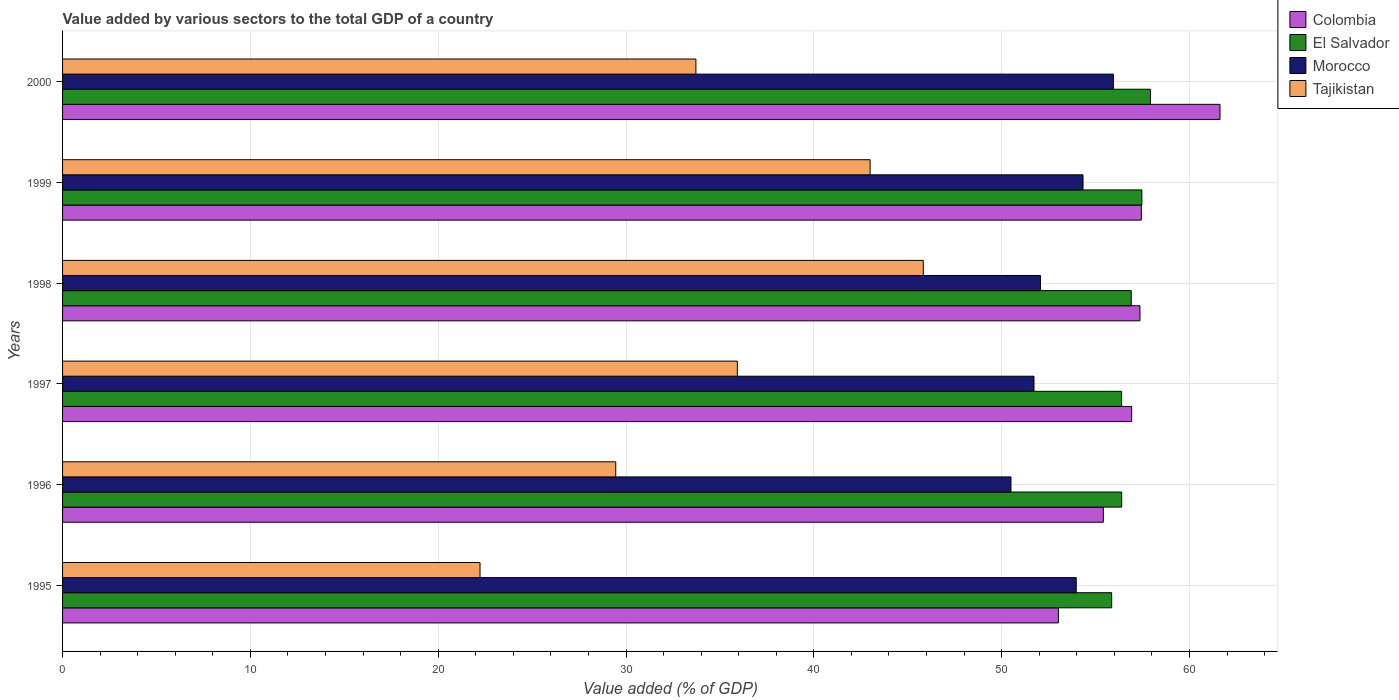How many different coloured bars are there?
Provide a short and direct response. 4. How many groups of bars are there?
Your answer should be compact. 6. How many bars are there on the 2nd tick from the bottom?
Your answer should be compact. 4. In how many cases, is the number of bars for a given year not equal to the number of legend labels?
Offer a terse response. 0. What is the value added by various sectors to the total GDP in Morocco in 1995?
Provide a succinct answer. 53.97. Across all years, what is the maximum value added by various sectors to the total GDP in Morocco?
Your answer should be very brief. 55.95. Across all years, what is the minimum value added by various sectors to the total GDP in Morocco?
Make the answer very short. 50.5. In which year was the value added by various sectors to the total GDP in Colombia maximum?
Your answer should be compact. 2000. What is the total value added by various sectors to the total GDP in Tajikistan in the graph?
Provide a short and direct response. 210.16. What is the difference between the value added by various sectors to the total GDP in Morocco in 1997 and that in 1999?
Your answer should be very brief. -2.61. What is the difference between the value added by various sectors to the total GDP in Colombia in 1998 and the value added by various sectors to the total GDP in Morocco in 1997?
Your answer should be compact. 5.64. What is the average value added by various sectors to the total GDP in El Salvador per year?
Offer a terse response. 56.82. In the year 2000, what is the difference between the value added by various sectors to the total GDP in Colombia and value added by various sectors to the total GDP in Tajikistan?
Make the answer very short. 27.91. What is the ratio of the value added by various sectors to the total GDP in Tajikistan in 1995 to that in 1997?
Make the answer very short. 0.62. Is the difference between the value added by various sectors to the total GDP in Colombia in 1997 and 2000 greater than the difference between the value added by various sectors to the total GDP in Tajikistan in 1997 and 2000?
Your answer should be compact. No. What is the difference between the highest and the second highest value added by various sectors to the total GDP in Tajikistan?
Give a very brief answer. 2.83. What is the difference between the highest and the lowest value added by various sectors to the total GDP in Morocco?
Provide a succinct answer. 5.45. What does the 4th bar from the top in 1999 represents?
Ensure brevity in your answer.  Colombia. How many bars are there?
Provide a short and direct response. 24. Does the graph contain any zero values?
Provide a short and direct response. No. Does the graph contain grids?
Your response must be concise. Yes. What is the title of the graph?
Provide a succinct answer. Value added by various sectors to the total GDP of a country. Does "Central Europe" appear as one of the legend labels in the graph?
Your answer should be very brief. No. What is the label or title of the X-axis?
Provide a succinct answer. Value added (% of GDP). What is the label or title of the Y-axis?
Give a very brief answer. Years. What is the Value added (% of GDP) of Colombia in 1995?
Offer a terse response. 53.02. What is the Value added (% of GDP) of El Salvador in 1995?
Your response must be concise. 55.86. What is the Value added (% of GDP) in Morocco in 1995?
Provide a succinct answer. 53.97. What is the Value added (% of GDP) in Tajikistan in 1995?
Your answer should be very brief. 22.23. What is the Value added (% of GDP) in Colombia in 1996?
Offer a terse response. 55.42. What is the Value added (% of GDP) in El Salvador in 1996?
Provide a short and direct response. 56.39. What is the Value added (% of GDP) in Morocco in 1996?
Make the answer very short. 50.5. What is the Value added (% of GDP) of Tajikistan in 1996?
Provide a short and direct response. 29.45. What is the Value added (% of GDP) of Colombia in 1997?
Provide a short and direct response. 56.92. What is the Value added (% of GDP) of El Salvador in 1997?
Give a very brief answer. 56.39. What is the Value added (% of GDP) in Morocco in 1997?
Make the answer very short. 51.72. What is the Value added (% of GDP) in Tajikistan in 1997?
Offer a very short reply. 35.93. What is the Value added (% of GDP) of Colombia in 1998?
Your answer should be compact. 57.37. What is the Value added (% of GDP) of El Salvador in 1998?
Ensure brevity in your answer.  56.9. What is the Value added (% of GDP) in Morocco in 1998?
Offer a terse response. 52.07. What is the Value added (% of GDP) of Tajikistan in 1998?
Your response must be concise. 45.83. What is the Value added (% of GDP) of Colombia in 1999?
Offer a terse response. 57.44. What is the Value added (% of GDP) of El Salvador in 1999?
Offer a very short reply. 57.47. What is the Value added (% of GDP) in Morocco in 1999?
Ensure brevity in your answer.  54.33. What is the Value added (% of GDP) in Tajikistan in 1999?
Your response must be concise. 43. What is the Value added (% of GDP) in Colombia in 2000?
Your response must be concise. 61.63. What is the Value added (% of GDP) of El Salvador in 2000?
Ensure brevity in your answer.  57.92. What is the Value added (% of GDP) of Morocco in 2000?
Your response must be concise. 55.95. What is the Value added (% of GDP) of Tajikistan in 2000?
Provide a succinct answer. 33.72. Across all years, what is the maximum Value added (% of GDP) in Colombia?
Provide a succinct answer. 61.63. Across all years, what is the maximum Value added (% of GDP) of El Salvador?
Keep it short and to the point. 57.92. Across all years, what is the maximum Value added (% of GDP) of Morocco?
Ensure brevity in your answer.  55.95. Across all years, what is the maximum Value added (% of GDP) of Tajikistan?
Offer a terse response. 45.83. Across all years, what is the minimum Value added (% of GDP) of Colombia?
Your answer should be very brief. 53.02. Across all years, what is the minimum Value added (% of GDP) of El Salvador?
Your answer should be compact. 55.86. Across all years, what is the minimum Value added (% of GDP) of Morocco?
Give a very brief answer. 50.5. Across all years, what is the minimum Value added (% of GDP) of Tajikistan?
Your response must be concise. 22.23. What is the total Value added (% of GDP) in Colombia in the graph?
Offer a terse response. 341.8. What is the total Value added (% of GDP) of El Salvador in the graph?
Make the answer very short. 340.93. What is the total Value added (% of GDP) in Morocco in the graph?
Provide a short and direct response. 318.55. What is the total Value added (% of GDP) in Tajikistan in the graph?
Your answer should be compact. 210.16. What is the difference between the Value added (% of GDP) in Colombia in 1995 and that in 1996?
Give a very brief answer. -2.39. What is the difference between the Value added (% of GDP) in El Salvador in 1995 and that in 1996?
Provide a short and direct response. -0.53. What is the difference between the Value added (% of GDP) of Morocco in 1995 and that in 1996?
Ensure brevity in your answer.  3.48. What is the difference between the Value added (% of GDP) in Tajikistan in 1995 and that in 1996?
Your answer should be compact. -7.23. What is the difference between the Value added (% of GDP) of Colombia in 1995 and that in 1997?
Your answer should be compact. -3.9. What is the difference between the Value added (% of GDP) in El Salvador in 1995 and that in 1997?
Your answer should be very brief. -0.53. What is the difference between the Value added (% of GDP) in Morocco in 1995 and that in 1997?
Your answer should be very brief. 2.25. What is the difference between the Value added (% of GDP) in Tajikistan in 1995 and that in 1997?
Keep it short and to the point. -13.7. What is the difference between the Value added (% of GDP) of Colombia in 1995 and that in 1998?
Offer a terse response. -4.34. What is the difference between the Value added (% of GDP) of El Salvador in 1995 and that in 1998?
Your answer should be very brief. -1.04. What is the difference between the Value added (% of GDP) of Morocco in 1995 and that in 1998?
Your response must be concise. 1.91. What is the difference between the Value added (% of GDP) in Tajikistan in 1995 and that in 1998?
Provide a succinct answer. -23.6. What is the difference between the Value added (% of GDP) in Colombia in 1995 and that in 1999?
Your answer should be very brief. -4.42. What is the difference between the Value added (% of GDP) of El Salvador in 1995 and that in 1999?
Provide a short and direct response. -1.61. What is the difference between the Value added (% of GDP) of Morocco in 1995 and that in 1999?
Make the answer very short. -0.36. What is the difference between the Value added (% of GDP) in Tajikistan in 1995 and that in 1999?
Offer a terse response. -20.77. What is the difference between the Value added (% of GDP) of Colombia in 1995 and that in 2000?
Your response must be concise. -8.6. What is the difference between the Value added (% of GDP) in El Salvador in 1995 and that in 2000?
Offer a terse response. -2.06. What is the difference between the Value added (% of GDP) of Morocco in 1995 and that in 2000?
Ensure brevity in your answer.  -1.98. What is the difference between the Value added (% of GDP) in Tajikistan in 1995 and that in 2000?
Provide a succinct answer. -11.5. What is the difference between the Value added (% of GDP) of Colombia in 1996 and that in 1997?
Ensure brevity in your answer.  -1.51. What is the difference between the Value added (% of GDP) in El Salvador in 1996 and that in 1997?
Provide a succinct answer. 0. What is the difference between the Value added (% of GDP) of Morocco in 1996 and that in 1997?
Provide a short and direct response. -1.23. What is the difference between the Value added (% of GDP) of Tajikistan in 1996 and that in 1997?
Provide a succinct answer. -6.48. What is the difference between the Value added (% of GDP) of Colombia in 1996 and that in 1998?
Provide a short and direct response. -1.95. What is the difference between the Value added (% of GDP) of El Salvador in 1996 and that in 1998?
Keep it short and to the point. -0.51. What is the difference between the Value added (% of GDP) of Morocco in 1996 and that in 1998?
Make the answer very short. -1.57. What is the difference between the Value added (% of GDP) of Tajikistan in 1996 and that in 1998?
Your response must be concise. -16.37. What is the difference between the Value added (% of GDP) of Colombia in 1996 and that in 1999?
Make the answer very short. -2.02. What is the difference between the Value added (% of GDP) of El Salvador in 1996 and that in 1999?
Ensure brevity in your answer.  -1.07. What is the difference between the Value added (% of GDP) in Morocco in 1996 and that in 1999?
Provide a succinct answer. -3.84. What is the difference between the Value added (% of GDP) of Tajikistan in 1996 and that in 1999?
Make the answer very short. -13.54. What is the difference between the Value added (% of GDP) in Colombia in 1996 and that in 2000?
Your response must be concise. -6.21. What is the difference between the Value added (% of GDP) in El Salvador in 1996 and that in 2000?
Offer a terse response. -1.53. What is the difference between the Value added (% of GDP) in Morocco in 1996 and that in 2000?
Your answer should be very brief. -5.45. What is the difference between the Value added (% of GDP) of Tajikistan in 1996 and that in 2000?
Offer a terse response. -4.27. What is the difference between the Value added (% of GDP) of Colombia in 1997 and that in 1998?
Your response must be concise. -0.44. What is the difference between the Value added (% of GDP) of El Salvador in 1997 and that in 1998?
Offer a very short reply. -0.51. What is the difference between the Value added (% of GDP) of Morocco in 1997 and that in 1998?
Your response must be concise. -0.34. What is the difference between the Value added (% of GDP) in Tajikistan in 1997 and that in 1998?
Provide a succinct answer. -9.9. What is the difference between the Value added (% of GDP) of Colombia in 1997 and that in 1999?
Give a very brief answer. -0.52. What is the difference between the Value added (% of GDP) of El Salvador in 1997 and that in 1999?
Provide a short and direct response. -1.08. What is the difference between the Value added (% of GDP) in Morocco in 1997 and that in 1999?
Provide a succinct answer. -2.61. What is the difference between the Value added (% of GDP) of Tajikistan in 1997 and that in 1999?
Ensure brevity in your answer.  -7.07. What is the difference between the Value added (% of GDP) of Colombia in 1997 and that in 2000?
Offer a very short reply. -4.7. What is the difference between the Value added (% of GDP) of El Salvador in 1997 and that in 2000?
Offer a terse response. -1.53. What is the difference between the Value added (% of GDP) in Morocco in 1997 and that in 2000?
Give a very brief answer. -4.23. What is the difference between the Value added (% of GDP) in Tajikistan in 1997 and that in 2000?
Your answer should be very brief. 2.21. What is the difference between the Value added (% of GDP) of Colombia in 1998 and that in 1999?
Make the answer very short. -0.07. What is the difference between the Value added (% of GDP) in El Salvador in 1998 and that in 1999?
Make the answer very short. -0.57. What is the difference between the Value added (% of GDP) in Morocco in 1998 and that in 1999?
Your answer should be compact. -2.27. What is the difference between the Value added (% of GDP) of Tajikistan in 1998 and that in 1999?
Make the answer very short. 2.83. What is the difference between the Value added (% of GDP) in Colombia in 1998 and that in 2000?
Offer a terse response. -4.26. What is the difference between the Value added (% of GDP) of El Salvador in 1998 and that in 2000?
Offer a terse response. -1.02. What is the difference between the Value added (% of GDP) in Morocco in 1998 and that in 2000?
Your answer should be very brief. -3.88. What is the difference between the Value added (% of GDP) in Tajikistan in 1998 and that in 2000?
Your answer should be very brief. 12.11. What is the difference between the Value added (% of GDP) in Colombia in 1999 and that in 2000?
Your response must be concise. -4.19. What is the difference between the Value added (% of GDP) in El Salvador in 1999 and that in 2000?
Provide a short and direct response. -0.46. What is the difference between the Value added (% of GDP) of Morocco in 1999 and that in 2000?
Make the answer very short. -1.62. What is the difference between the Value added (% of GDP) of Tajikistan in 1999 and that in 2000?
Give a very brief answer. 9.27. What is the difference between the Value added (% of GDP) in Colombia in 1995 and the Value added (% of GDP) in El Salvador in 1996?
Offer a very short reply. -3.37. What is the difference between the Value added (% of GDP) of Colombia in 1995 and the Value added (% of GDP) of Morocco in 1996?
Give a very brief answer. 2.53. What is the difference between the Value added (% of GDP) of Colombia in 1995 and the Value added (% of GDP) of Tajikistan in 1996?
Provide a succinct answer. 23.57. What is the difference between the Value added (% of GDP) in El Salvador in 1995 and the Value added (% of GDP) in Morocco in 1996?
Your answer should be compact. 5.36. What is the difference between the Value added (% of GDP) in El Salvador in 1995 and the Value added (% of GDP) in Tajikistan in 1996?
Offer a terse response. 26.41. What is the difference between the Value added (% of GDP) in Morocco in 1995 and the Value added (% of GDP) in Tajikistan in 1996?
Keep it short and to the point. 24.52. What is the difference between the Value added (% of GDP) in Colombia in 1995 and the Value added (% of GDP) in El Salvador in 1997?
Give a very brief answer. -3.36. What is the difference between the Value added (% of GDP) of Colombia in 1995 and the Value added (% of GDP) of Morocco in 1997?
Make the answer very short. 1.3. What is the difference between the Value added (% of GDP) in Colombia in 1995 and the Value added (% of GDP) in Tajikistan in 1997?
Make the answer very short. 17.09. What is the difference between the Value added (% of GDP) of El Salvador in 1995 and the Value added (% of GDP) of Morocco in 1997?
Ensure brevity in your answer.  4.14. What is the difference between the Value added (% of GDP) of El Salvador in 1995 and the Value added (% of GDP) of Tajikistan in 1997?
Your answer should be compact. 19.93. What is the difference between the Value added (% of GDP) in Morocco in 1995 and the Value added (% of GDP) in Tajikistan in 1997?
Provide a short and direct response. 18.04. What is the difference between the Value added (% of GDP) of Colombia in 1995 and the Value added (% of GDP) of El Salvador in 1998?
Your response must be concise. -3.88. What is the difference between the Value added (% of GDP) in Colombia in 1995 and the Value added (% of GDP) in Morocco in 1998?
Make the answer very short. 0.96. What is the difference between the Value added (% of GDP) of Colombia in 1995 and the Value added (% of GDP) of Tajikistan in 1998?
Your answer should be compact. 7.19. What is the difference between the Value added (% of GDP) in El Salvador in 1995 and the Value added (% of GDP) in Morocco in 1998?
Provide a succinct answer. 3.79. What is the difference between the Value added (% of GDP) of El Salvador in 1995 and the Value added (% of GDP) of Tajikistan in 1998?
Give a very brief answer. 10.03. What is the difference between the Value added (% of GDP) of Morocco in 1995 and the Value added (% of GDP) of Tajikistan in 1998?
Keep it short and to the point. 8.14. What is the difference between the Value added (% of GDP) of Colombia in 1995 and the Value added (% of GDP) of El Salvador in 1999?
Your response must be concise. -4.44. What is the difference between the Value added (% of GDP) in Colombia in 1995 and the Value added (% of GDP) in Morocco in 1999?
Provide a succinct answer. -1.31. What is the difference between the Value added (% of GDP) of Colombia in 1995 and the Value added (% of GDP) of Tajikistan in 1999?
Give a very brief answer. 10.03. What is the difference between the Value added (% of GDP) in El Salvador in 1995 and the Value added (% of GDP) in Morocco in 1999?
Offer a terse response. 1.53. What is the difference between the Value added (% of GDP) in El Salvador in 1995 and the Value added (% of GDP) in Tajikistan in 1999?
Offer a terse response. 12.86. What is the difference between the Value added (% of GDP) of Morocco in 1995 and the Value added (% of GDP) of Tajikistan in 1999?
Ensure brevity in your answer.  10.98. What is the difference between the Value added (% of GDP) of Colombia in 1995 and the Value added (% of GDP) of El Salvador in 2000?
Your answer should be compact. -4.9. What is the difference between the Value added (% of GDP) of Colombia in 1995 and the Value added (% of GDP) of Morocco in 2000?
Make the answer very short. -2.93. What is the difference between the Value added (% of GDP) of Colombia in 1995 and the Value added (% of GDP) of Tajikistan in 2000?
Make the answer very short. 19.3. What is the difference between the Value added (% of GDP) in El Salvador in 1995 and the Value added (% of GDP) in Morocco in 2000?
Keep it short and to the point. -0.09. What is the difference between the Value added (% of GDP) in El Salvador in 1995 and the Value added (% of GDP) in Tajikistan in 2000?
Your answer should be compact. 22.14. What is the difference between the Value added (% of GDP) in Morocco in 1995 and the Value added (% of GDP) in Tajikistan in 2000?
Provide a short and direct response. 20.25. What is the difference between the Value added (% of GDP) of Colombia in 1996 and the Value added (% of GDP) of El Salvador in 1997?
Your response must be concise. -0.97. What is the difference between the Value added (% of GDP) in Colombia in 1996 and the Value added (% of GDP) in Morocco in 1997?
Your response must be concise. 3.69. What is the difference between the Value added (% of GDP) of Colombia in 1996 and the Value added (% of GDP) of Tajikistan in 1997?
Offer a terse response. 19.49. What is the difference between the Value added (% of GDP) in El Salvador in 1996 and the Value added (% of GDP) in Morocco in 1997?
Give a very brief answer. 4.67. What is the difference between the Value added (% of GDP) of El Salvador in 1996 and the Value added (% of GDP) of Tajikistan in 1997?
Your answer should be compact. 20.46. What is the difference between the Value added (% of GDP) in Morocco in 1996 and the Value added (% of GDP) in Tajikistan in 1997?
Ensure brevity in your answer.  14.57. What is the difference between the Value added (% of GDP) in Colombia in 1996 and the Value added (% of GDP) in El Salvador in 1998?
Your answer should be very brief. -1.49. What is the difference between the Value added (% of GDP) of Colombia in 1996 and the Value added (% of GDP) of Morocco in 1998?
Your answer should be compact. 3.35. What is the difference between the Value added (% of GDP) of Colombia in 1996 and the Value added (% of GDP) of Tajikistan in 1998?
Provide a succinct answer. 9.59. What is the difference between the Value added (% of GDP) of El Salvador in 1996 and the Value added (% of GDP) of Morocco in 1998?
Your answer should be very brief. 4.32. What is the difference between the Value added (% of GDP) of El Salvador in 1996 and the Value added (% of GDP) of Tajikistan in 1998?
Your response must be concise. 10.56. What is the difference between the Value added (% of GDP) in Morocco in 1996 and the Value added (% of GDP) in Tajikistan in 1998?
Your answer should be compact. 4.67. What is the difference between the Value added (% of GDP) in Colombia in 1996 and the Value added (% of GDP) in El Salvador in 1999?
Provide a short and direct response. -2.05. What is the difference between the Value added (% of GDP) in Colombia in 1996 and the Value added (% of GDP) in Morocco in 1999?
Keep it short and to the point. 1.08. What is the difference between the Value added (% of GDP) in Colombia in 1996 and the Value added (% of GDP) in Tajikistan in 1999?
Your answer should be compact. 12.42. What is the difference between the Value added (% of GDP) in El Salvador in 1996 and the Value added (% of GDP) in Morocco in 1999?
Your answer should be compact. 2.06. What is the difference between the Value added (% of GDP) of El Salvador in 1996 and the Value added (% of GDP) of Tajikistan in 1999?
Offer a very short reply. 13.39. What is the difference between the Value added (% of GDP) in Morocco in 1996 and the Value added (% of GDP) in Tajikistan in 1999?
Provide a succinct answer. 7.5. What is the difference between the Value added (% of GDP) of Colombia in 1996 and the Value added (% of GDP) of El Salvador in 2000?
Offer a terse response. -2.51. What is the difference between the Value added (% of GDP) of Colombia in 1996 and the Value added (% of GDP) of Morocco in 2000?
Offer a terse response. -0.54. What is the difference between the Value added (% of GDP) of Colombia in 1996 and the Value added (% of GDP) of Tajikistan in 2000?
Your answer should be very brief. 21.69. What is the difference between the Value added (% of GDP) of El Salvador in 1996 and the Value added (% of GDP) of Morocco in 2000?
Give a very brief answer. 0.44. What is the difference between the Value added (% of GDP) in El Salvador in 1996 and the Value added (% of GDP) in Tajikistan in 2000?
Offer a terse response. 22.67. What is the difference between the Value added (% of GDP) in Morocco in 1996 and the Value added (% of GDP) in Tajikistan in 2000?
Offer a terse response. 16.77. What is the difference between the Value added (% of GDP) in Colombia in 1997 and the Value added (% of GDP) in El Salvador in 1998?
Your response must be concise. 0.02. What is the difference between the Value added (% of GDP) of Colombia in 1997 and the Value added (% of GDP) of Morocco in 1998?
Offer a very short reply. 4.86. What is the difference between the Value added (% of GDP) in Colombia in 1997 and the Value added (% of GDP) in Tajikistan in 1998?
Make the answer very short. 11.09. What is the difference between the Value added (% of GDP) of El Salvador in 1997 and the Value added (% of GDP) of Morocco in 1998?
Your answer should be compact. 4.32. What is the difference between the Value added (% of GDP) in El Salvador in 1997 and the Value added (% of GDP) in Tajikistan in 1998?
Provide a succinct answer. 10.56. What is the difference between the Value added (% of GDP) of Morocco in 1997 and the Value added (% of GDP) of Tajikistan in 1998?
Ensure brevity in your answer.  5.89. What is the difference between the Value added (% of GDP) of Colombia in 1997 and the Value added (% of GDP) of El Salvador in 1999?
Give a very brief answer. -0.54. What is the difference between the Value added (% of GDP) of Colombia in 1997 and the Value added (% of GDP) of Morocco in 1999?
Provide a short and direct response. 2.59. What is the difference between the Value added (% of GDP) of Colombia in 1997 and the Value added (% of GDP) of Tajikistan in 1999?
Give a very brief answer. 13.93. What is the difference between the Value added (% of GDP) of El Salvador in 1997 and the Value added (% of GDP) of Morocco in 1999?
Your answer should be compact. 2.05. What is the difference between the Value added (% of GDP) in El Salvador in 1997 and the Value added (% of GDP) in Tajikistan in 1999?
Your answer should be very brief. 13.39. What is the difference between the Value added (% of GDP) of Morocco in 1997 and the Value added (% of GDP) of Tajikistan in 1999?
Give a very brief answer. 8.73. What is the difference between the Value added (% of GDP) in Colombia in 1997 and the Value added (% of GDP) in El Salvador in 2000?
Offer a terse response. -1. What is the difference between the Value added (% of GDP) in Colombia in 1997 and the Value added (% of GDP) in Morocco in 2000?
Your response must be concise. 0.97. What is the difference between the Value added (% of GDP) in Colombia in 1997 and the Value added (% of GDP) in Tajikistan in 2000?
Your answer should be compact. 23.2. What is the difference between the Value added (% of GDP) of El Salvador in 1997 and the Value added (% of GDP) of Morocco in 2000?
Keep it short and to the point. 0.44. What is the difference between the Value added (% of GDP) of El Salvador in 1997 and the Value added (% of GDP) of Tajikistan in 2000?
Give a very brief answer. 22.67. What is the difference between the Value added (% of GDP) in Morocco in 1997 and the Value added (% of GDP) in Tajikistan in 2000?
Your answer should be compact. 18. What is the difference between the Value added (% of GDP) in Colombia in 1998 and the Value added (% of GDP) in El Salvador in 1999?
Your response must be concise. -0.1. What is the difference between the Value added (% of GDP) of Colombia in 1998 and the Value added (% of GDP) of Morocco in 1999?
Give a very brief answer. 3.03. What is the difference between the Value added (% of GDP) in Colombia in 1998 and the Value added (% of GDP) in Tajikistan in 1999?
Provide a short and direct response. 14.37. What is the difference between the Value added (% of GDP) in El Salvador in 1998 and the Value added (% of GDP) in Morocco in 1999?
Provide a short and direct response. 2.57. What is the difference between the Value added (% of GDP) of El Salvador in 1998 and the Value added (% of GDP) of Tajikistan in 1999?
Offer a terse response. 13.9. What is the difference between the Value added (% of GDP) of Morocco in 1998 and the Value added (% of GDP) of Tajikistan in 1999?
Provide a short and direct response. 9.07. What is the difference between the Value added (% of GDP) of Colombia in 1998 and the Value added (% of GDP) of El Salvador in 2000?
Ensure brevity in your answer.  -0.56. What is the difference between the Value added (% of GDP) of Colombia in 1998 and the Value added (% of GDP) of Morocco in 2000?
Give a very brief answer. 1.41. What is the difference between the Value added (% of GDP) in Colombia in 1998 and the Value added (% of GDP) in Tajikistan in 2000?
Offer a very short reply. 23.64. What is the difference between the Value added (% of GDP) in El Salvador in 1998 and the Value added (% of GDP) in Morocco in 2000?
Your answer should be very brief. 0.95. What is the difference between the Value added (% of GDP) of El Salvador in 1998 and the Value added (% of GDP) of Tajikistan in 2000?
Your response must be concise. 23.18. What is the difference between the Value added (% of GDP) in Morocco in 1998 and the Value added (% of GDP) in Tajikistan in 2000?
Provide a short and direct response. 18.34. What is the difference between the Value added (% of GDP) of Colombia in 1999 and the Value added (% of GDP) of El Salvador in 2000?
Give a very brief answer. -0.48. What is the difference between the Value added (% of GDP) of Colombia in 1999 and the Value added (% of GDP) of Morocco in 2000?
Your answer should be very brief. 1.49. What is the difference between the Value added (% of GDP) in Colombia in 1999 and the Value added (% of GDP) in Tajikistan in 2000?
Make the answer very short. 23.72. What is the difference between the Value added (% of GDP) in El Salvador in 1999 and the Value added (% of GDP) in Morocco in 2000?
Provide a short and direct response. 1.52. What is the difference between the Value added (% of GDP) in El Salvador in 1999 and the Value added (% of GDP) in Tajikistan in 2000?
Provide a short and direct response. 23.74. What is the difference between the Value added (% of GDP) of Morocco in 1999 and the Value added (% of GDP) of Tajikistan in 2000?
Provide a succinct answer. 20.61. What is the average Value added (% of GDP) of Colombia per year?
Your answer should be compact. 56.97. What is the average Value added (% of GDP) of El Salvador per year?
Offer a terse response. 56.82. What is the average Value added (% of GDP) in Morocco per year?
Make the answer very short. 53.09. What is the average Value added (% of GDP) of Tajikistan per year?
Make the answer very short. 35.03. In the year 1995, what is the difference between the Value added (% of GDP) of Colombia and Value added (% of GDP) of El Salvador?
Ensure brevity in your answer.  -2.84. In the year 1995, what is the difference between the Value added (% of GDP) of Colombia and Value added (% of GDP) of Morocco?
Make the answer very short. -0.95. In the year 1995, what is the difference between the Value added (% of GDP) of Colombia and Value added (% of GDP) of Tajikistan?
Your response must be concise. 30.8. In the year 1995, what is the difference between the Value added (% of GDP) in El Salvador and Value added (% of GDP) in Morocco?
Keep it short and to the point. 1.89. In the year 1995, what is the difference between the Value added (% of GDP) of El Salvador and Value added (% of GDP) of Tajikistan?
Give a very brief answer. 33.63. In the year 1995, what is the difference between the Value added (% of GDP) of Morocco and Value added (% of GDP) of Tajikistan?
Your answer should be compact. 31.75. In the year 1996, what is the difference between the Value added (% of GDP) of Colombia and Value added (% of GDP) of El Salvador?
Make the answer very short. -0.98. In the year 1996, what is the difference between the Value added (% of GDP) of Colombia and Value added (% of GDP) of Morocco?
Keep it short and to the point. 4.92. In the year 1996, what is the difference between the Value added (% of GDP) of Colombia and Value added (% of GDP) of Tajikistan?
Your answer should be very brief. 25.96. In the year 1996, what is the difference between the Value added (% of GDP) of El Salvador and Value added (% of GDP) of Morocco?
Give a very brief answer. 5.89. In the year 1996, what is the difference between the Value added (% of GDP) of El Salvador and Value added (% of GDP) of Tajikistan?
Give a very brief answer. 26.94. In the year 1996, what is the difference between the Value added (% of GDP) of Morocco and Value added (% of GDP) of Tajikistan?
Your answer should be compact. 21.04. In the year 1997, what is the difference between the Value added (% of GDP) of Colombia and Value added (% of GDP) of El Salvador?
Make the answer very short. 0.54. In the year 1997, what is the difference between the Value added (% of GDP) of Colombia and Value added (% of GDP) of Morocco?
Keep it short and to the point. 5.2. In the year 1997, what is the difference between the Value added (% of GDP) of Colombia and Value added (% of GDP) of Tajikistan?
Make the answer very short. 20.99. In the year 1997, what is the difference between the Value added (% of GDP) in El Salvador and Value added (% of GDP) in Morocco?
Offer a very short reply. 4.66. In the year 1997, what is the difference between the Value added (% of GDP) of El Salvador and Value added (% of GDP) of Tajikistan?
Ensure brevity in your answer.  20.46. In the year 1997, what is the difference between the Value added (% of GDP) in Morocco and Value added (% of GDP) in Tajikistan?
Make the answer very short. 15.79. In the year 1998, what is the difference between the Value added (% of GDP) of Colombia and Value added (% of GDP) of El Salvador?
Provide a succinct answer. 0.46. In the year 1998, what is the difference between the Value added (% of GDP) of Colombia and Value added (% of GDP) of Morocco?
Your answer should be very brief. 5.3. In the year 1998, what is the difference between the Value added (% of GDP) in Colombia and Value added (% of GDP) in Tajikistan?
Offer a terse response. 11.54. In the year 1998, what is the difference between the Value added (% of GDP) in El Salvador and Value added (% of GDP) in Morocco?
Your answer should be compact. 4.83. In the year 1998, what is the difference between the Value added (% of GDP) of El Salvador and Value added (% of GDP) of Tajikistan?
Give a very brief answer. 11.07. In the year 1998, what is the difference between the Value added (% of GDP) of Morocco and Value added (% of GDP) of Tajikistan?
Give a very brief answer. 6.24. In the year 1999, what is the difference between the Value added (% of GDP) in Colombia and Value added (% of GDP) in El Salvador?
Give a very brief answer. -0.03. In the year 1999, what is the difference between the Value added (% of GDP) of Colombia and Value added (% of GDP) of Morocco?
Offer a very short reply. 3.11. In the year 1999, what is the difference between the Value added (% of GDP) in Colombia and Value added (% of GDP) in Tajikistan?
Your response must be concise. 14.44. In the year 1999, what is the difference between the Value added (% of GDP) of El Salvador and Value added (% of GDP) of Morocco?
Provide a short and direct response. 3.13. In the year 1999, what is the difference between the Value added (% of GDP) of El Salvador and Value added (% of GDP) of Tajikistan?
Keep it short and to the point. 14.47. In the year 1999, what is the difference between the Value added (% of GDP) of Morocco and Value added (% of GDP) of Tajikistan?
Your response must be concise. 11.34. In the year 2000, what is the difference between the Value added (% of GDP) of Colombia and Value added (% of GDP) of El Salvador?
Provide a succinct answer. 3.71. In the year 2000, what is the difference between the Value added (% of GDP) in Colombia and Value added (% of GDP) in Morocco?
Offer a very short reply. 5.68. In the year 2000, what is the difference between the Value added (% of GDP) of Colombia and Value added (% of GDP) of Tajikistan?
Offer a very short reply. 27.91. In the year 2000, what is the difference between the Value added (% of GDP) of El Salvador and Value added (% of GDP) of Morocco?
Give a very brief answer. 1.97. In the year 2000, what is the difference between the Value added (% of GDP) in El Salvador and Value added (% of GDP) in Tajikistan?
Make the answer very short. 24.2. In the year 2000, what is the difference between the Value added (% of GDP) of Morocco and Value added (% of GDP) of Tajikistan?
Provide a short and direct response. 22.23. What is the ratio of the Value added (% of GDP) of Colombia in 1995 to that in 1996?
Offer a terse response. 0.96. What is the ratio of the Value added (% of GDP) in El Salvador in 1995 to that in 1996?
Ensure brevity in your answer.  0.99. What is the ratio of the Value added (% of GDP) of Morocco in 1995 to that in 1996?
Offer a terse response. 1.07. What is the ratio of the Value added (% of GDP) of Tajikistan in 1995 to that in 1996?
Your answer should be compact. 0.75. What is the ratio of the Value added (% of GDP) in Colombia in 1995 to that in 1997?
Make the answer very short. 0.93. What is the ratio of the Value added (% of GDP) of El Salvador in 1995 to that in 1997?
Your answer should be very brief. 0.99. What is the ratio of the Value added (% of GDP) of Morocco in 1995 to that in 1997?
Give a very brief answer. 1.04. What is the ratio of the Value added (% of GDP) in Tajikistan in 1995 to that in 1997?
Keep it short and to the point. 0.62. What is the ratio of the Value added (% of GDP) of Colombia in 1995 to that in 1998?
Give a very brief answer. 0.92. What is the ratio of the Value added (% of GDP) of El Salvador in 1995 to that in 1998?
Provide a succinct answer. 0.98. What is the ratio of the Value added (% of GDP) of Morocco in 1995 to that in 1998?
Offer a very short reply. 1.04. What is the ratio of the Value added (% of GDP) in Tajikistan in 1995 to that in 1998?
Offer a very short reply. 0.48. What is the ratio of the Value added (% of GDP) of Colombia in 1995 to that in 1999?
Offer a very short reply. 0.92. What is the ratio of the Value added (% of GDP) of El Salvador in 1995 to that in 1999?
Make the answer very short. 0.97. What is the ratio of the Value added (% of GDP) in Morocco in 1995 to that in 1999?
Your answer should be very brief. 0.99. What is the ratio of the Value added (% of GDP) in Tajikistan in 1995 to that in 1999?
Provide a succinct answer. 0.52. What is the ratio of the Value added (% of GDP) of Colombia in 1995 to that in 2000?
Your answer should be very brief. 0.86. What is the ratio of the Value added (% of GDP) in El Salvador in 1995 to that in 2000?
Provide a short and direct response. 0.96. What is the ratio of the Value added (% of GDP) of Morocco in 1995 to that in 2000?
Offer a terse response. 0.96. What is the ratio of the Value added (% of GDP) of Tajikistan in 1995 to that in 2000?
Provide a short and direct response. 0.66. What is the ratio of the Value added (% of GDP) in Colombia in 1996 to that in 1997?
Your answer should be very brief. 0.97. What is the ratio of the Value added (% of GDP) in El Salvador in 1996 to that in 1997?
Offer a very short reply. 1. What is the ratio of the Value added (% of GDP) in Morocco in 1996 to that in 1997?
Give a very brief answer. 0.98. What is the ratio of the Value added (% of GDP) in Tajikistan in 1996 to that in 1997?
Provide a short and direct response. 0.82. What is the ratio of the Value added (% of GDP) of El Salvador in 1996 to that in 1998?
Provide a short and direct response. 0.99. What is the ratio of the Value added (% of GDP) of Morocco in 1996 to that in 1998?
Your answer should be compact. 0.97. What is the ratio of the Value added (% of GDP) of Tajikistan in 1996 to that in 1998?
Your answer should be compact. 0.64. What is the ratio of the Value added (% of GDP) in Colombia in 1996 to that in 1999?
Keep it short and to the point. 0.96. What is the ratio of the Value added (% of GDP) of El Salvador in 1996 to that in 1999?
Ensure brevity in your answer.  0.98. What is the ratio of the Value added (% of GDP) in Morocco in 1996 to that in 1999?
Your answer should be very brief. 0.93. What is the ratio of the Value added (% of GDP) in Tajikistan in 1996 to that in 1999?
Offer a terse response. 0.69. What is the ratio of the Value added (% of GDP) in Colombia in 1996 to that in 2000?
Give a very brief answer. 0.9. What is the ratio of the Value added (% of GDP) of El Salvador in 1996 to that in 2000?
Your answer should be compact. 0.97. What is the ratio of the Value added (% of GDP) in Morocco in 1996 to that in 2000?
Your answer should be very brief. 0.9. What is the ratio of the Value added (% of GDP) in Tajikistan in 1996 to that in 2000?
Give a very brief answer. 0.87. What is the ratio of the Value added (% of GDP) of Colombia in 1997 to that in 1998?
Provide a short and direct response. 0.99. What is the ratio of the Value added (% of GDP) of El Salvador in 1997 to that in 1998?
Make the answer very short. 0.99. What is the ratio of the Value added (% of GDP) of Morocco in 1997 to that in 1998?
Provide a short and direct response. 0.99. What is the ratio of the Value added (% of GDP) of Tajikistan in 1997 to that in 1998?
Your response must be concise. 0.78. What is the ratio of the Value added (% of GDP) in Colombia in 1997 to that in 1999?
Provide a short and direct response. 0.99. What is the ratio of the Value added (% of GDP) in El Salvador in 1997 to that in 1999?
Your answer should be compact. 0.98. What is the ratio of the Value added (% of GDP) in Tajikistan in 1997 to that in 1999?
Provide a short and direct response. 0.84. What is the ratio of the Value added (% of GDP) in Colombia in 1997 to that in 2000?
Your response must be concise. 0.92. What is the ratio of the Value added (% of GDP) of El Salvador in 1997 to that in 2000?
Give a very brief answer. 0.97. What is the ratio of the Value added (% of GDP) of Morocco in 1997 to that in 2000?
Make the answer very short. 0.92. What is the ratio of the Value added (% of GDP) of Tajikistan in 1997 to that in 2000?
Ensure brevity in your answer.  1.07. What is the ratio of the Value added (% of GDP) in Colombia in 1998 to that in 1999?
Offer a terse response. 1. What is the ratio of the Value added (% of GDP) in El Salvador in 1998 to that in 1999?
Ensure brevity in your answer.  0.99. What is the ratio of the Value added (% of GDP) of Morocco in 1998 to that in 1999?
Make the answer very short. 0.96. What is the ratio of the Value added (% of GDP) in Tajikistan in 1998 to that in 1999?
Keep it short and to the point. 1.07. What is the ratio of the Value added (% of GDP) of Colombia in 1998 to that in 2000?
Your answer should be very brief. 0.93. What is the ratio of the Value added (% of GDP) of El Salvador in 1998 to that in 2000?
Offer a very short reply. 0.98. What is the ratio of the Value added (% of GDP) of Morocco in 1998 to that in 2000?
Your answer should be compact. 0.93. What is the ratio of the Value added (% of GDP) of Tajikistan in 1998 to that in 2000?
Offer a terse response. 1.36. What is the ratio of the Value added (% of GDP) in Colombia in 1999 to that in 2000?
Give a very brief answer. 0.93. What is the ratio of the Value added (% of GDP) in El Salvador in 1999 to that in 2000?
Your answer should be compact. 0.99. What is the ratio of the Value added (% of GDP) in Morocco in 1999 to that in 2000?
Keep it short and to the point. 0.97. What is the ratio of the Value added (% of GDP) in Tajikistan in 1999 to that in 2000?
Ensure brevity in your answer.  1.27. What is the difference between the highest and the second highest Value added (% of GDP) of Colombia?
Provide a succinct answer. 4.19. What is the difference between the highest and the second highest Value added (% of GDP) in El Salvador?
Keep it short and to the point. 0.46. What is the difference between the highest and the second highest Value added (% of GDP) of Morocco?
Make the answer very short. 1.62. What is the difference between the highest and the second highest Value added (% of GDP) in Tajikistan?
Provide a short and direct response. 2.83. What is the difference between the highest and the lowest Value added (% of GDP) in Colombia?
Provide a short and direct response. 8.6. What is the difference between the highest and the lowest Value added (% of GDP) in El Salvador?
Provide a succinct answer. 2.06. What is the difference between the highest and the lowest Value added (% of GDP) in Morocco?
Offer a very short reply. 5.45. What is the difference between the highest and the lowest Value added (% of GDP) of Tajikistan?
Give a very brief answer. 23.6. 